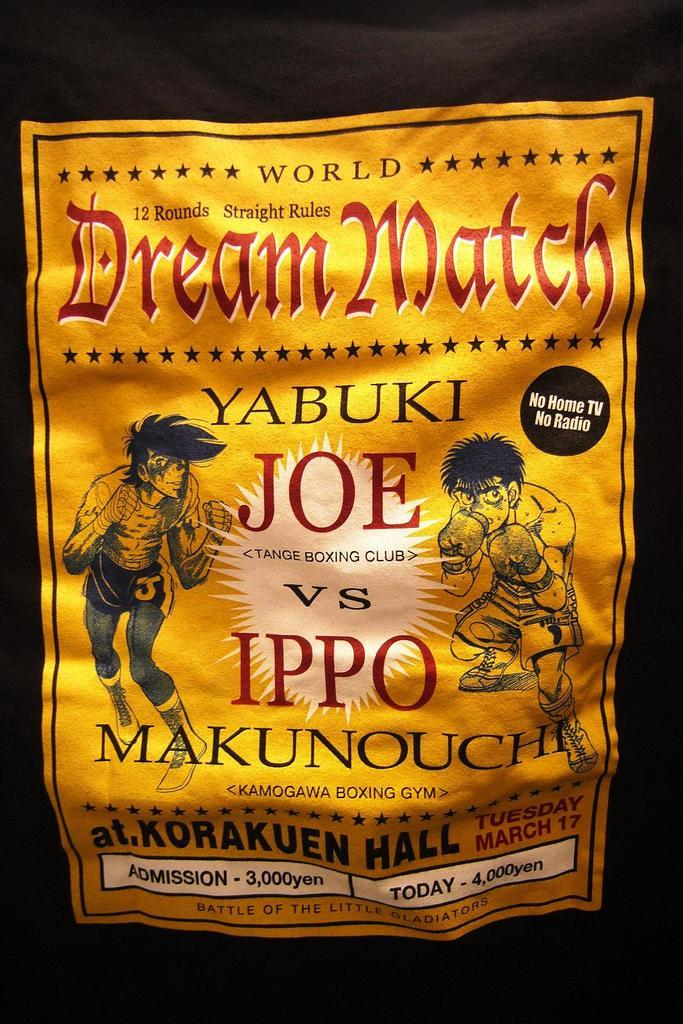What is present in the image that features a visual representation? There is a poster in the image. What type of characters are depicted on the poster? The poster contains cartoons of two persons. Is there any text present on the poster? Yes, there is text on the poster. What type of stick can be seen in the image? There is no stick present in the image. How low is the poster hanging in the image? The facts provided do not give information about the height or position of the poster in the image. 